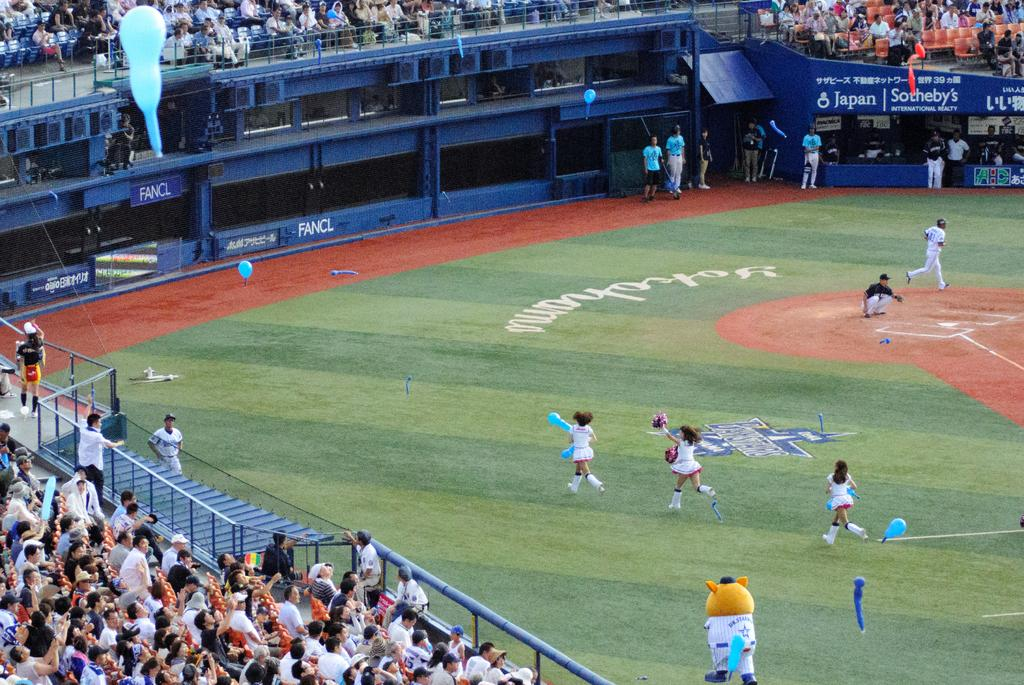<image>
Share a concise interpretation of the image provided. An advertisement for Sotheby's hangs at a sporting event. 